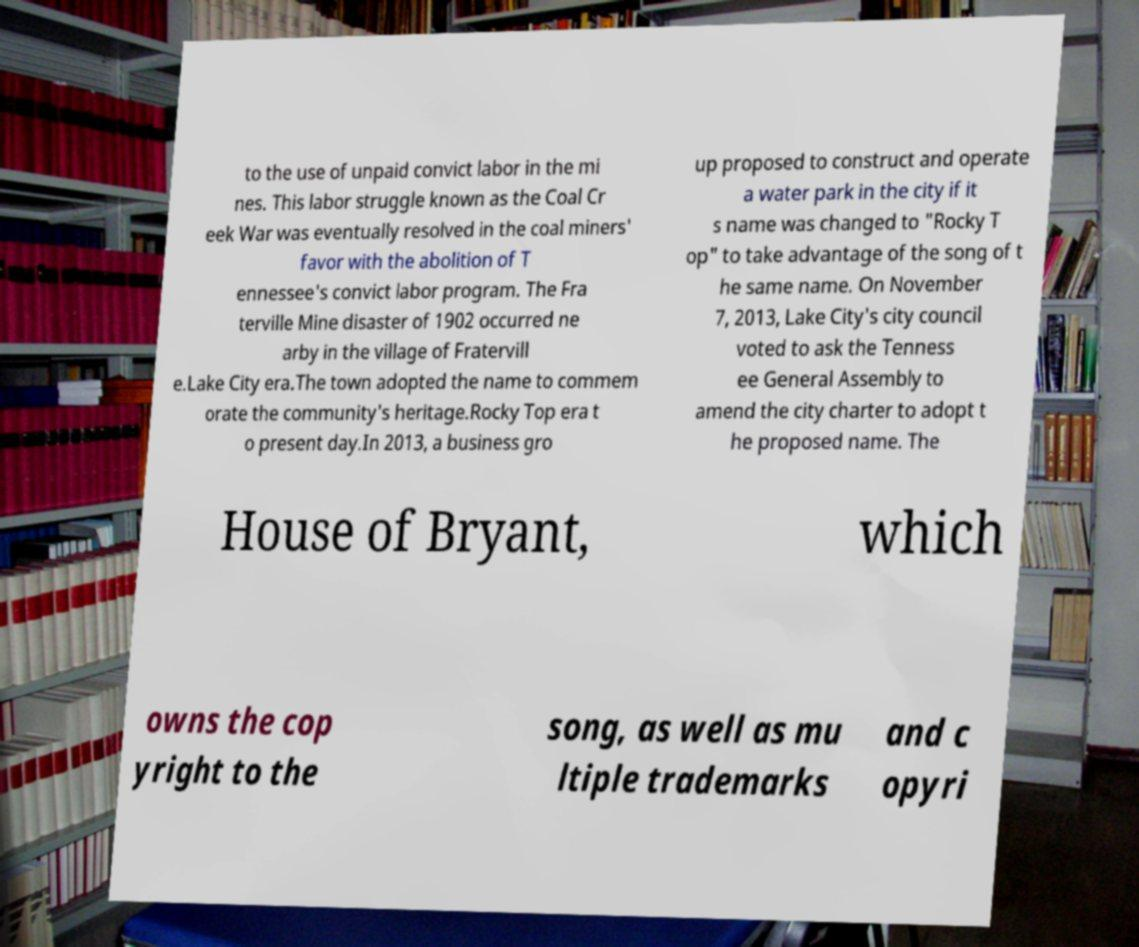Could you assist in decoding the text presented in this image and type it out clearly? to the use of unpaid convict labor in the mi nes. This labor struggle known as the Coal Cr eek War was eventually resolved in the coal miners' favor with the abolition of T ennessee's convict labor program. The Fra terville Mine disaster of 1902 occurred ne arby in the village of Fratervill e.Lake City era.The town adopted the name to commem orate the community's heritage.Rocky Top era t o present day.In 2013, a business gro up proposed to construct and operate a water park in the city if it s name was changed to "Rocky T op" to take advantage of the song of t he same name. On November 7, 2013, Lake City's city council voted to ask the Tenness ee General Assembly to amend the city charter to adopt t he proposed name. The House of Bryant, which owns the cop yright to the song, as well as mu ltiple trademarks and c opyri 